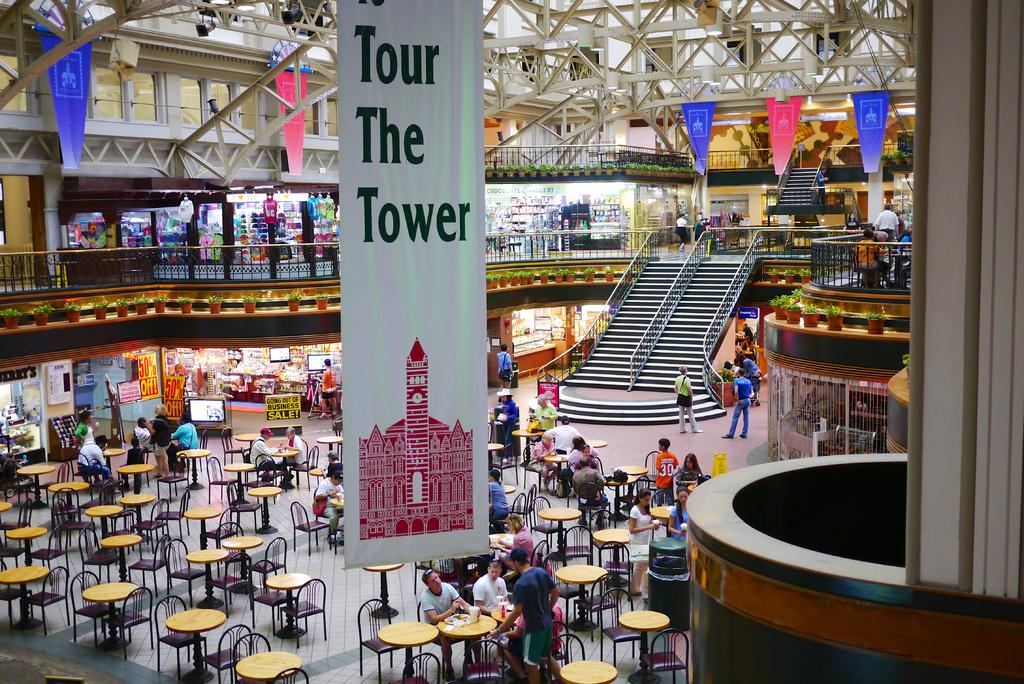<image>
Write a terse but informative summary of the picture. Tour The Tower is written on a white banner inside of a mall 